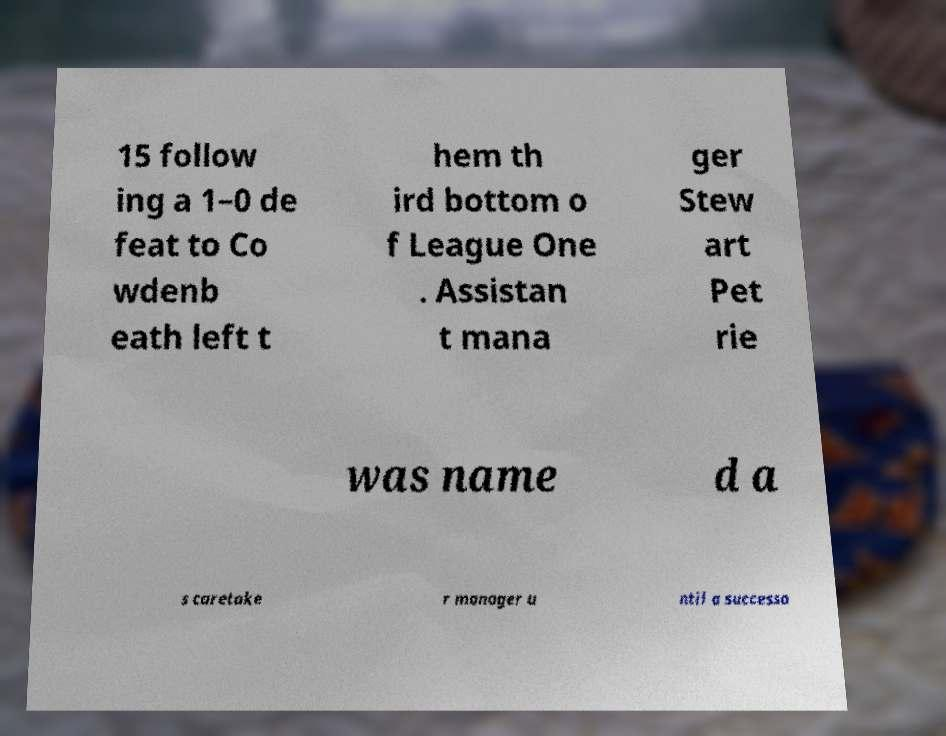For documentation purposes, I need the text within this image transcribed. Could you provide that? 15 follow ing a 1–0 de feat to Co wdenb eath left t hem th ird bottom o f League One . Assistan t mana ger Stew art Pet rie was name d a s caretake r manager u ntil a successo 